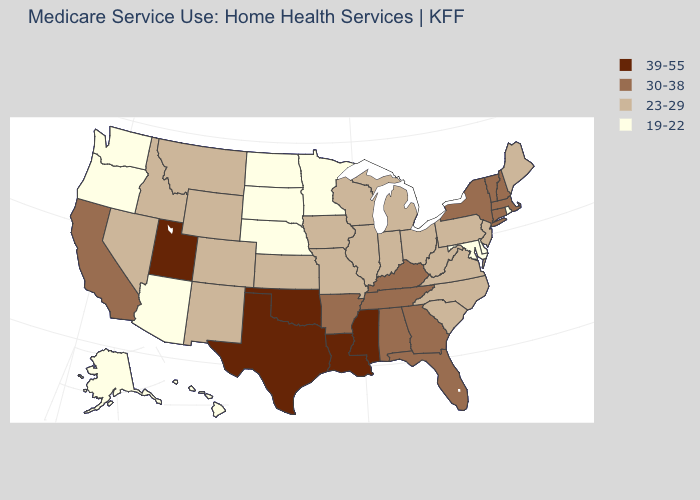Among the states that border Maryland , does Virginia have the highest value?
Answer briefly. Yes. Does the first symbol in the legend represent the smallest category?
Short answer required. No. What is the value of Alabama?
Write a very short answer. 30-38. What is the value of Delaware?
Answer briefly. 19-22. Name the states that have a value in the range 39-55?
Quick response, please. Louisiana, Mississippi, Oklahoma, Texas, Utah. Is the legend a continuous bar?
Answer briefly. No. Name the states that have a value in the range 39-55?
Short answer required. Louisiana, Mississippi, Oklahoma, Texas, Utah. What is the lowest value in the USA?
Short answer required. 19-22. Is the legend a continuous bar?
Keep it brief. No. Which states hav the highest value in the MidWest?
Answer briefly. Illinois, Indiana, Iowa, Kansas, Michigan, Missouri, Ohio, Wisconsin. Name the states that have a value in the range 30-38?
Keep it brief. Alabama, Arkansas, California, Connecticut, Florida, Georgia, Kentucky, Massachusetts, New Hampshire, New York, Tennessee, Vermont. Which states have the lowest value in the USA?
Answer briefly. Alaska, Arizona, Delaware, Hawaii, Maryland, Minnesota, Nebraska, North Dakota, Oregon, Rhode Island, South Dakota, Washington. What is the lowest value in states that border Texas?
Short answer required. 23-29. Does Michigan have a higher value than Arizona?
Keep it brief. Yes. Which states have the highest value in the USA?
Give a very brief answer. Louisiana, Mississippi, Oklahoma, Texas, Utah. 